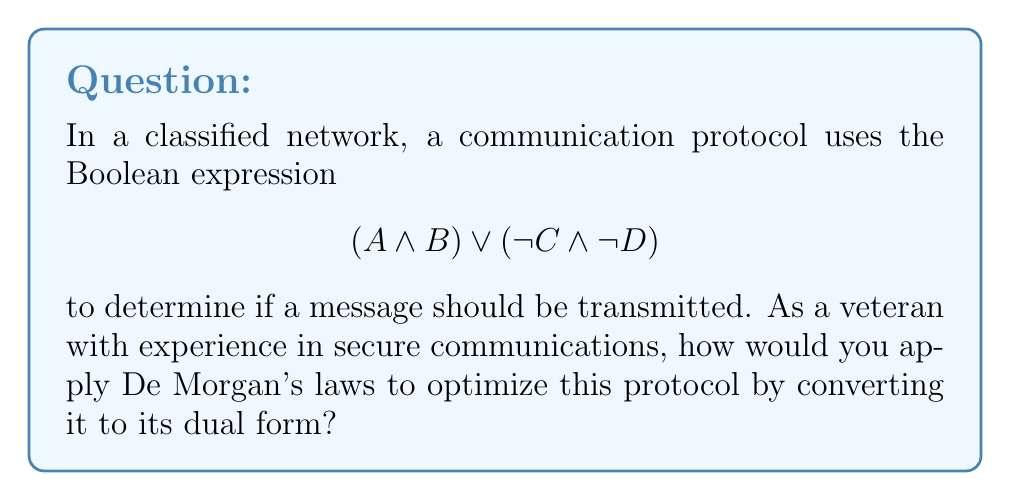Show me your answer to this math problem. To optimize the communication protocol using De Morgan's laws, we'll convert the given expression to its dual form. This process involves the following steps:

1. Apply De Morgan's law to the entire expression:
   $\neg((A \land B) \lor (\neg C \land \neg D))$

2. Distribute the negation using De Morgan's law:
   $(\neg(A \land B)) \land (\neg(\neg C \land \neg D))$

3. Apply De Morgan's law to each parenthesized expression:
   $(\neg A \lor \neg B) \land (C \lor D)$

4. This result is the dual form of the original expression. It's optimized because:
   a) It reduces the number of NOT operations from two to one.
   b) It simplifies the logic, potentially reducing processing time.
   c) It may be easier to implement in hardware or software.

5. To verify, we can apply De Morgan's law again to this result:
   $\neg((\neg A \lor \neg B) \land (C \lor D))$
   $(A \land B) \lor (\neg C \land \neg D)$
   This brings us back to the original expression, confirming the correctness of our optimization.
Answer: $(\neg A \lor \neg B) \land (C \lor D)$ 